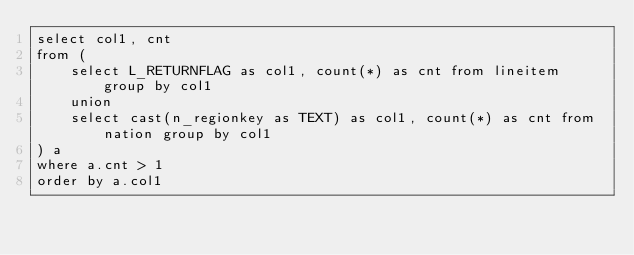Convert code to text. <code><loc_0><loc_0><loc_500><loc_500><_SQL_>select col1, cnt
from (
    select L_RETURNFLAG as col1, count(*) as cnt from lineitem group by col1
    union
    select cast(n_regionkey as TEXT) as col1, count(*) as cnt from nation group by col1
) a
where a.cnt > 1
order by a.col1</code> 